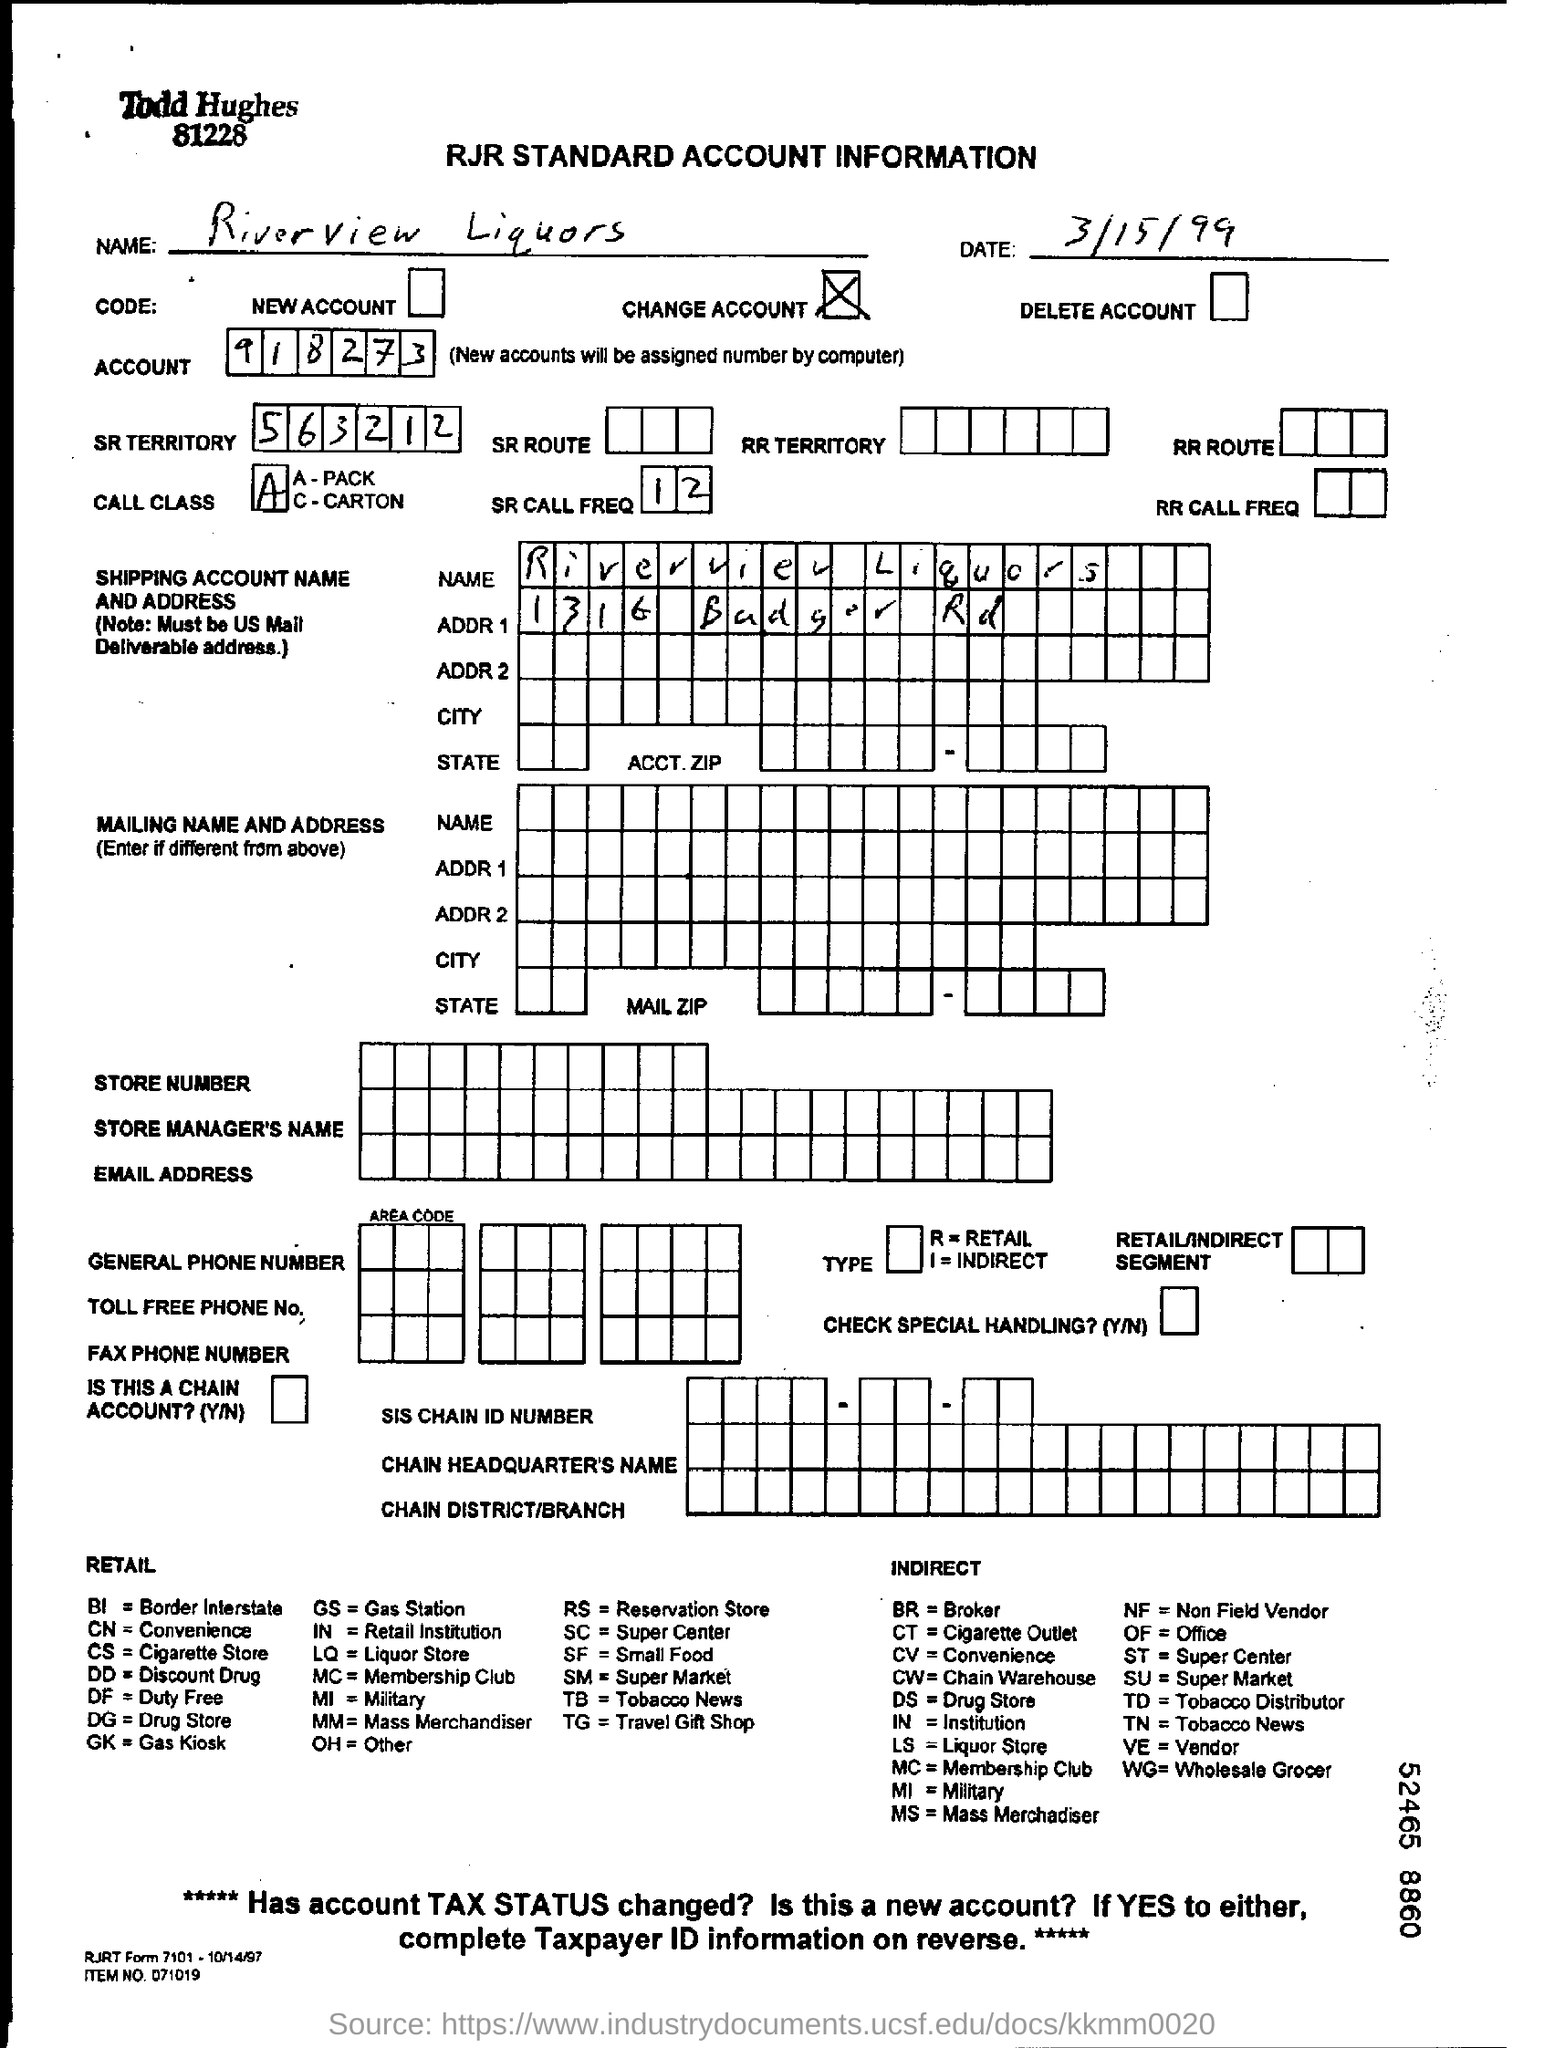What is the name mentioned?
Ensure brevity in your answer.  Riverview Liquors. What is the date mentioned?
Give a very brief answer. 3/15/99. What is the ACCOUNT number mentioned?
Ensure brevity in your answer.  918273. What is the SR TERRITORY number mentioned?
Your answer should be very brief. 563212. 